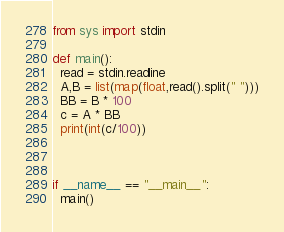<code> <loc_0><loc_0><loc_500><loc_500><_Python_>from sys import stdin

def main():
  read = stdin.readline
  A,B = list(map(float,read().split(" ")))
  BB = B * 100
  c = A * BB
  print(int(c/100))
  
  
  
if __name__ == "__main__":
  main()</code> 